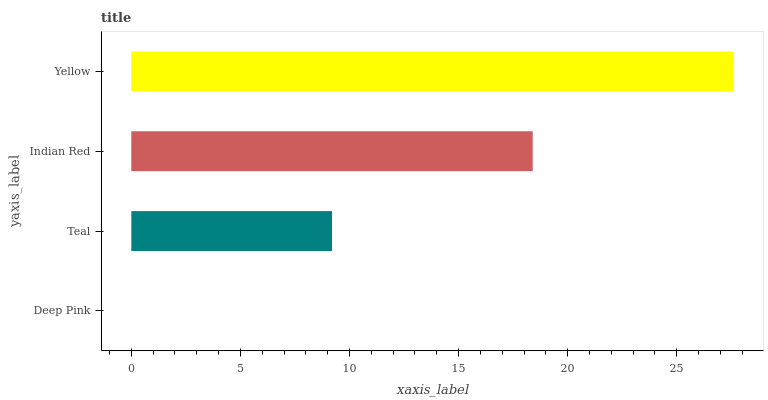Is Deep Pink the minimum?
Answer yes or no. Yes. Is Yellow the maximum?
Answer yes or no. Yes. Is Teal the minimum?
Answer yes or no. No. Is Teal the maximum?
Answer yes or no. No. Is Teal greater than Deep Pink?
Answer yes or no. Yes. Is Deep Pink less than Teal?
Answer yes or no. Yes. Is Deep Pink greater than Teal?
Answer yes or no. No. Is Teal less than Deep Pink?
Answer yes or no. No. Is Indian Red the high median?
Answer yes or no. Yes. Is Teal the low median?
Answer yes or no. Yes. Is Deep Pink the high median?
Answer yes or no. No. Is Deep Pink the low median?
Answer yes or no. No. 